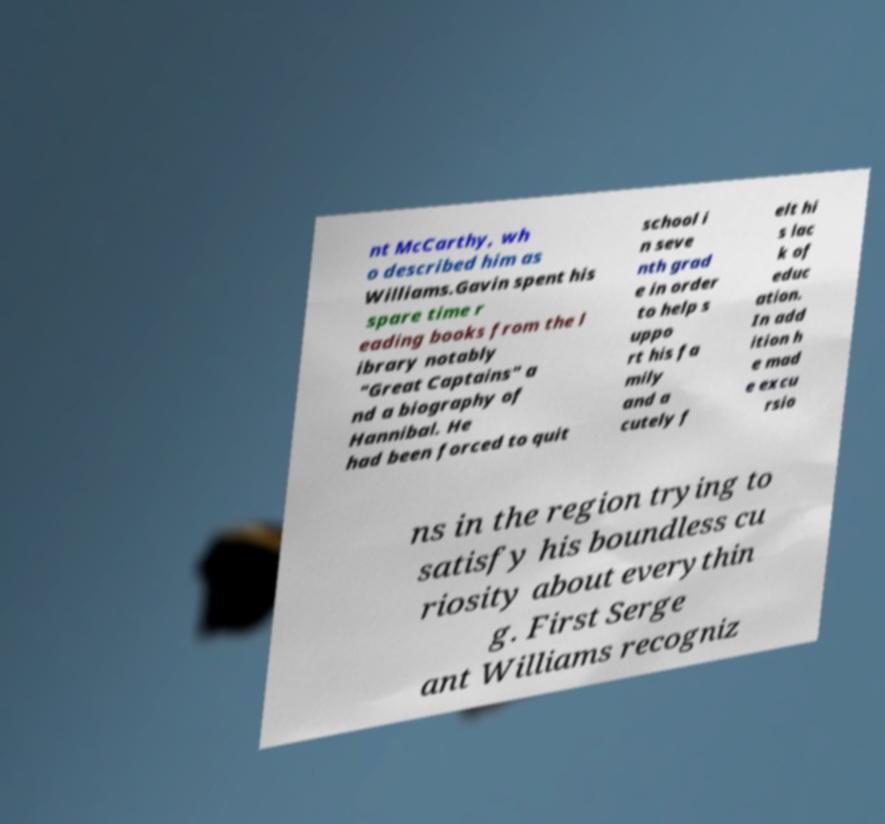Could you extract and type out the text from this image? nt McCarthy, wh o described him as Williams.Gavin spent his spare time r eading books from the l ibrary notably "Great Captains" a nd a biography of Hannibal. He had been forced to quit school i n seve nth grad e in order to help s uppo rt his fa mily and a cutely f elt hi s lac k of educ ation. In add ition h e mad e excu rsio ns in the region trying to satisfy his boundless cu riosity about everythin g. First Serge ant Williams recogniz 